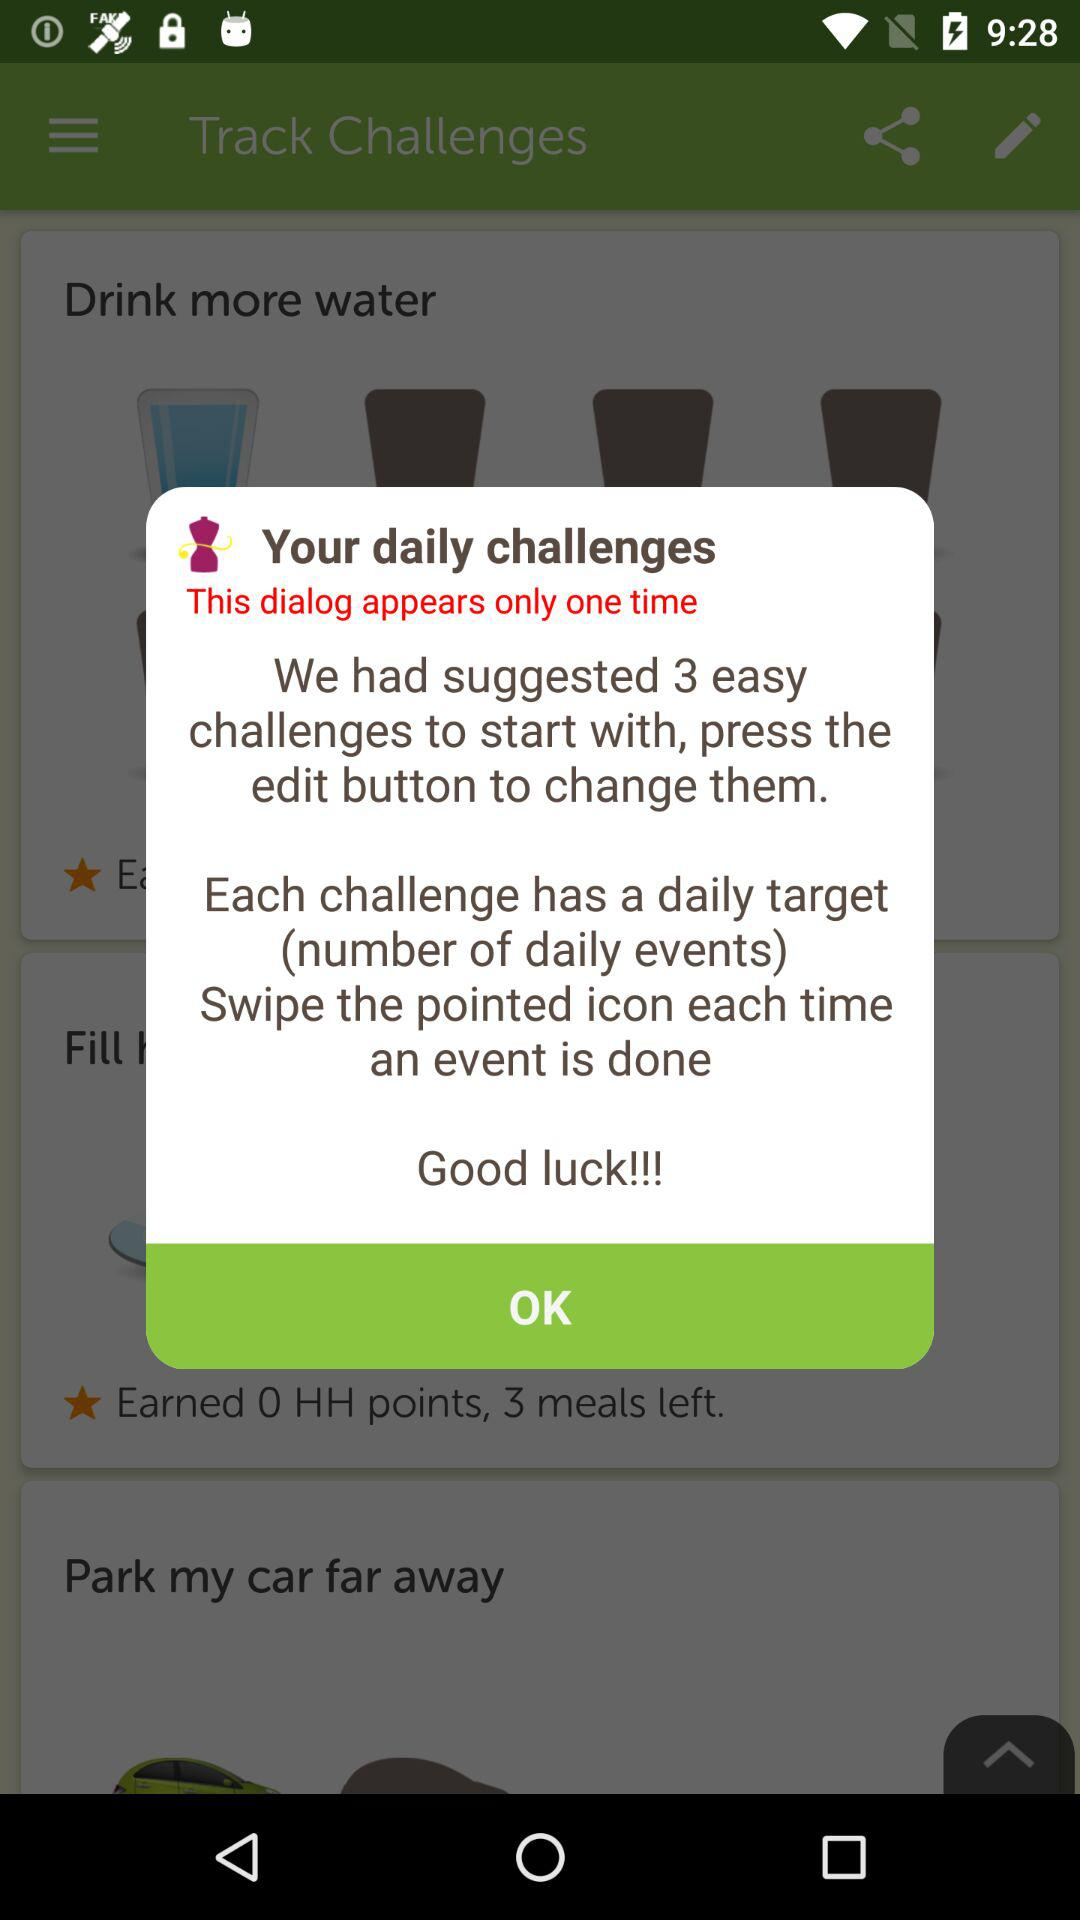How many challenges are suggested to start with?
Answer the question using a single word or phrase. 3 